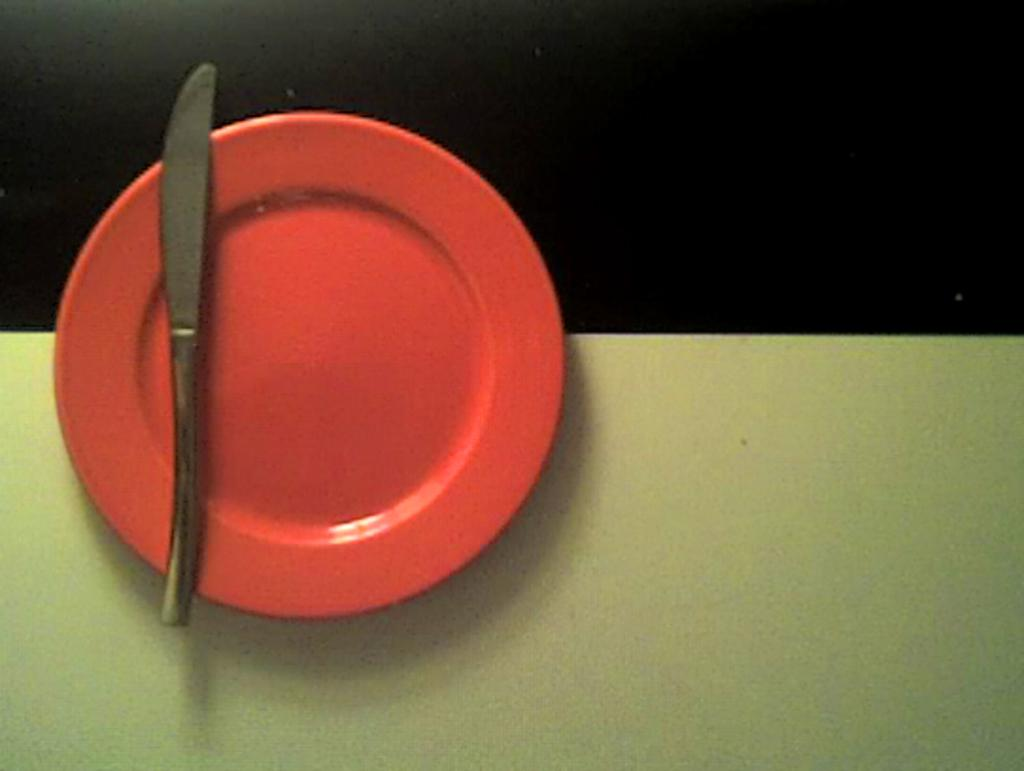What is placed on the orange color plate in the image? There is a knife on an orange color plate in the image. What is the color of the surface on which the plate is placed? The plate is on a white color surface. How would you describe the background of the image? The background of the image is dark in color. How many keys are visible on the plate in the image? There are no keys present on the plate in the image; it only has a knife. Are there any giants visible in the image? There are no giants present in the image. 